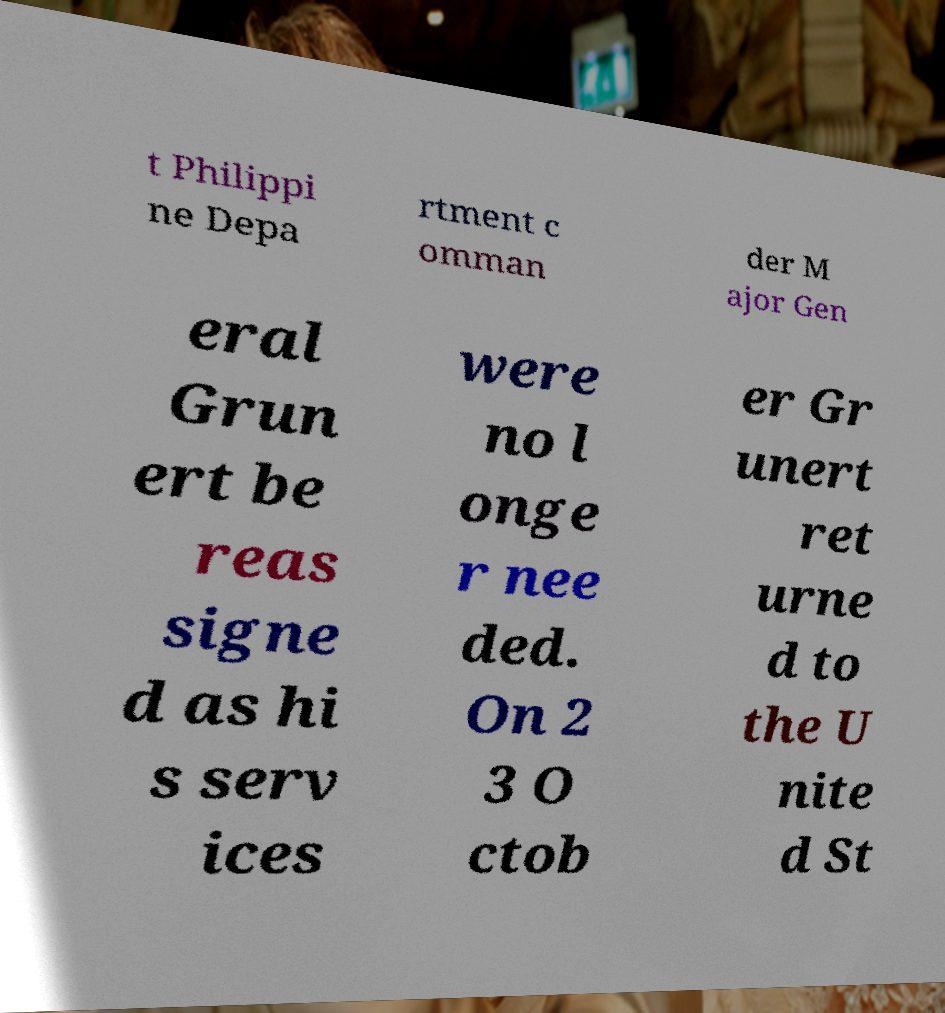What messages or text are displayed in this image? I need them in a readable, typed format. t Philippi ne Depa rtment c omman der M ajor Gen eral Grun ert be reas signe d as hi s serv ices were no l onge r nee ded. On 2 3 O ctob er Gr unert ret urne d to the U nite d St 